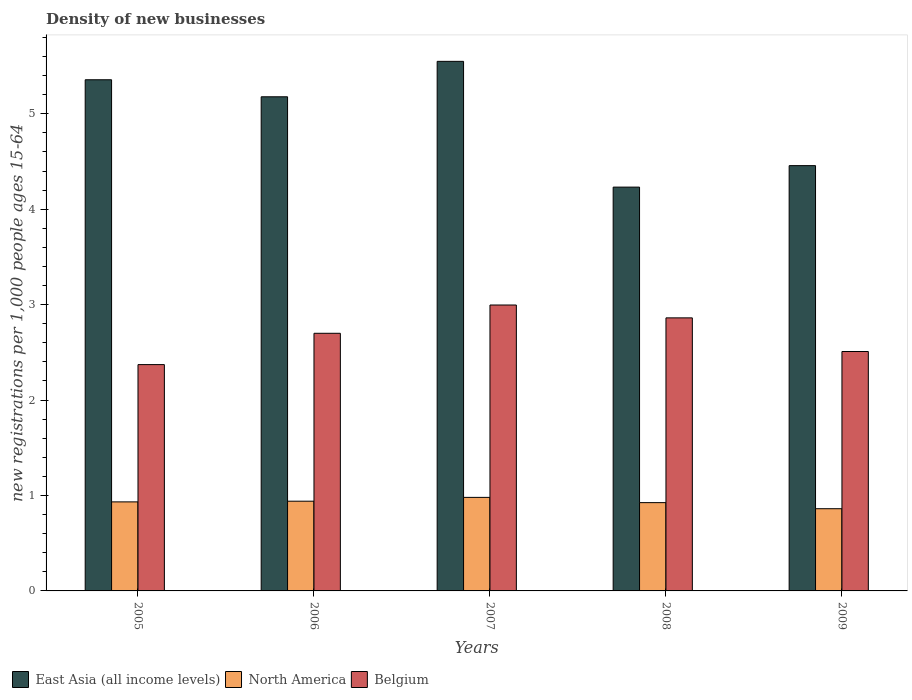How many groups of bars are there?
Make the answer very short. 5. Are the number of bars on each tick of the X-axis equal?
Make the answer very short. Yes. How many bars are there on the 2nd tick from the left?
Your answer should be compact. 3. How many bars are there on the 4th tick from the right?
Keep it short and to the point. 3. What is the label of the 3rd group of bars from the left?
Offer a very short reply. 2007. In how many cases, is the number of bars for a given year not equal to the number of legend labels?
Your answer should be very brief. 0. What is the number of new registrations in East Asia (all income levels) in 2008?
Your response must be concise. 4.23. Across all years, what is the maximum number of new registrations in North America?
Your response must be concise. 0.98. Across all years, what is the minimum number of new registrations in Belgium?
Offer a very short reply. 2.37. In which year was the number of new registrations in North America maximum?
Your answer should be very brief. 2007. In which year was the number of new registrations in East Asia (all income levels) minimum?
Make the answer very short. 2008. What is the total number of new registrations in Belgium in the graph?
Provide a succinct answer. 13.44. What is the difference between the number of new registrations in Belgium in 2005 and that in 2008?
Your response must be concise. -0.49. What is the difference between the number of new registrations in North America in 2008 and the number of new registrations in East Asia (all income levels) in 2007?
Provide a short and direct response. -4.62. What is the average number of new registrations in North America per year?
Provide a succinct answer. 0.93. In the year 2009, what is the difference between the number of new registrations in Belgium and number of new registrations in East Asia (all income levels)?
Your answer should be compact. -1.95. In how many years, is the number of new registrations in East Asia (all income levels) greater than 3.4?
Your answer should be very brief. 5. What is the ratio of the number of new registrations in North America in 2005 to that in 2007?
Offer a very short reply. 0.95. Is the number of new registrations in Belgium in 2008 less than that in 2009?
Provide a succinct answer. No. Is the difference between the number of new registrations in Belgium in 2008 and 2009 greater than the difference between the number of new registrations in East Asia (all income levels) in 2008 and 2009?
Your answer should be compact. Yes. What is the difference between the highest and the second highest number of new registrations in North America?
Make the answer very short. 0.04. What is the difference between the highest and the lowest number of new registrations in East Asia (all income levels)?
Give a very brief answer. 1.32. What does the 3rd bar from the left in 2008 represents?
Offer a terse response. Belgium. What does the 1st bar from the right in 2005 represents?
Your answer should be very brief. Belgium. Are all the bars in the graph horizontal?
Keep it short and to the point. No. Are the values on the major ticks of Y-axis written in scientific E-notation?
Your answer should be very brief. No. Where does the legend appear in the graph?
Give a very brief answer. Bottom left. What is the title of the graph?
Make the answer very short. Density of new businesses. What is the label or title of the X-axis?
Your answer should be very brief. Years. What is the label or title of the Y-axis?
Offer a terse response. New registrations per 1,0 people ages 15-64. What is the new registrations per 1,000 people ages 15-64 in East Asia (all income levels) in 2005?
Your answer should be very brief. 5.36. What is the new registrations per 1,000 people ages 15-64 in North America in 2005?
Your response must be concise. 0.93. What is the new registrations per 1,000 people ages 15-64 in Belgium in 2005?
Make the answer very short. 2.37. What is the new registrations per 1,000 people ages 15-64 in East Asia (all income levels) in 2006?
Provide a short and direct response. 5.18. What is the new registrations per 1,000 people ages 15-64 of North America in 2006?
Your answer should be compact. 0.94. What is the new registrations per 1,000 people ages 15-64 in Belgium in 2006?
Provide a succinct answer. 2.7. What is the new registrations per 1,000 people ages 15-64 in East Asia (all income levels) in 2007?
Your response must be concise. 5.55. What is the new registrations per 1,000 people ages 15-64 in North America in 2007?
Make the answer very short. 0.98. What is the new registrations per 1,000 people ages 15-64 in Belgium in 2007?
Give a very brief answer. 3. What is the new registrations per 1,000 people ages 15-64 in East Asia (all income levels) in 2008?
Give a very brief answer. 4.23. What is the new registrations per 1,000 people ages 15-64 in North America in 2008?
Offer a terse response. 0.93. What is the new registrations per 1,000 people ages 15-64 in Belgium in 2008?
Offer a terse response. 2.86. What is the new registrations per 1,000 people ages 15-64 in East Asia (all income levels) in 2009?
Give a very brief answer. 4.46. What is the new registrations per 1,000 people ages 15-64 in North America in 2009?
Ensure brevity in your answer.  0.86. What is the new registrations per 1,000 people ages 15-64 in Belgium in 2009?
Provide a succinct answer. 2.51. Across all years, what is the maximum new registrations per 1,000 people ages 15-64 in East Asia (all income levels)?
Your response must be concise. 5.55. Across all years, what is the maximum new registrations per 1,000 people ages 15-64 of North America?
Make the answer very short. 0.98. Across all years, what is the maximum new registrations per 1,000 people ages 15-64 of Belgium?
Offer a terse response. 3. Across all years, what is the minimum new registrations per 1,000 people ages 15-64 in East Asia (all income levels)?
Make the answer very short. 4.23. Across all years, what is the minimum new registrations per 1,000 people ages 15-64 in North America?
Provide a succinct answer. 0.86. Across all years, what is the minimum new registrations per 1,000 people ages 15-64 in Belgium?
Provide a short and direct response. 2.37. What is the total new registrations per 1,000 people ages 15-64 in East Asia (all income levels) in the graph?
Provide a short and direct response. 24.77. What is the total new registrations per 1,000 people ages 15-64 of North America in the graph?
Your answer should be very brief. 4.64. What is the total new registrations per 1,000 people ages 15-64 in Belgium in the graph?
Your response must be concise. 13.44. What is the difference between the new registrations per 1,000 people ages 15-64 of East Asia (all income levels) in 2005 and that in 2006?
Your answer should be very brief. 0.18. What is the difference between the new registrations per 1,000 people ages 15-64 of North America in 2005 and that in 2006?
Your answer should be very brief. -0.01. What is the difference between the new registrations per 1,000 people ages 15-64 in Belgium in 2005 and that in 2006?
Your answer should be compact. -0.33. What is the difference between the new registrations per 1,000 people ages 15-64 of East Asia (all income levels) in 2005 and that in 2007?
Offer a terse response. -0.19. What is the difference between the new registrations per 1,000 people ages 15-64 of North America in 2005 and that in 2007?
Give a very brief answer. -0.05. What is the difference between the new registrations per 1,000 people ages 15-64 of Belgium in 2005 and that in 2007?
Offer a terse response. -0.62. What is the difference between the new registrations per 1,000 people ages 15-64 of East Asia (all income levels) in 2005 and that in 2008?
Provide a short and direct response. 1.12. What is the difference between the new registrations per 1,000 people ages 15-64 in North America in 2005 and that in 2008?
Ensure brevity in your answer.  0.01. What is the difference between the new registrations per 1,000 people ages 15-64 in Belgium in 2005 and that in 2008?
Your response must be concise. -0.49. What is the difference between the new registrations per 1,000 people ages 15-64 of East Asia (all income levels) in 2005 and that in 2009?
Offer a very short reply. 0.9. What is the difference between the new registrations per 1,000 people ages 15-64 in North America in 2005 and that in 2009?
Your answer should be compact. 0.07. What is the difference between the new registrations per 1,000 people ages 15-64 of Belgium in 2005 and that in 2009?
Your response must be concise. -0.14. What is the difference between the new registrations per 1,000 people ages 15-64 in East Asia (all income levels) in 2006 and that in 2007?
Provide a succinct answer. -0.37. What is the difference between the new registrations per 1,000 people ages 15-64 in North America in 2006 and that in 2007?
Provide a succinct answer. -0.04. What is the difference between the new registrations per 1,000 people ages 15-64 in Belgium in 2006 and that in 2007?
Provide a short and direct response. -0.3. What is the difference between the new registrations per 1,000 people ages 15-64 in East Asia (all income levels) in 2006 and that in 2008?
Offer a very short reply. 0.95. What is the difference between the new registrations per 1,000 people ages 15-64 of North America in 2006 and that in 2008?
Keep it short and to the point. 0.01. What is the difference between the new registrations per 1,000 people ages 15-64 in Belgium in 2006 and that in 2008?
Make the answer very short. -0.16. What is the difference between the new registrations per 1,000 people ages 15-64 of East Asia (all income levels) in 2006 and that in 2009?
Offer a very short reply. 0.72. What is the difference between the new registrations per 1,000 people ages 15-64 in North America in 2006 and that in 2009?
Offer a terse response. 0.08. What is the difference between the new registrations per 1,000 people ages 15-64 in Belgium in 2006 and that in 2009?
Offer a terse response. 0.19. What is the difference between the new registrations per 1,000 people ages 15-64 of East Asia (all income levels) in 2007 and that in 2008?
Keep it short and to the point. 1.32. What is the difference between the new registrations per 1,000 people ages 15-64 of North America in 2007 and that in 2008?
Give a very brief answer. 0.06. What is the difference between the new registrations per 1,000 people ages 15-64 in Belgium in 2007 and that in 2008?
Provide a short and direct response. 0.13. What is the difference between the new registrations per 1,000 people ages 15-64 in East Asia (all income levels) in 2007 and that in 2009?
Provide a short and direct response. 1.09. What is the difference between the new registrations per 1,000 people ages 15-64 of North America in 2007 and that in 2009?
Give a very brief answer. 0.12. What is the difference between the new registrations per 1,000 people ages 15-64 in Belgium in 2007 and that in 2009?
Provide a succinct answer. 0.49. What is the difference between the new registrations per 1,000 people ages 15-64 of East Asia (all income levels) in 2008 and that in 2009?
Provide a succinct answer. -0.23. What is the difference between the new registrations per 1,000 people ages 15-64 in North America in 2008 and that in 2009?
Your answer should be very brief. 0.06. What is the difference between the new registrations per 1,000 people ages 15-64 in Belgium in 2008 and that in 2009?
Offer a terse response. 0.35. What is the difference between the new registrations per 1,000 people ages 15-64 in East Asia (all income levels) in 2005 and the new registrations per 1,000 people ages 15-64 in North America in 2006?
Offer a terse response. 4.42. What is the difference between the new registrations per 1,000 people ages 15-64 in East Asia (all income levels) in 2005 and the new registrations per 1,000 people ages 15-64 in Belgium in 2006?
Make the answer very short. 2.66. What is the difference between the new registrations per 1,000 people ages 15-64 of North America in 2005 and the new registrations per 1,000 people ages 15-64 of Belgium in 2006?
Offer a very short reply. -1.77. What is the difference between the new registrations per 1,000 people ages 15-64 in East Asia (all income levels) in 2005 and the new registrations per 1,000 people ages 15-64 in North America in 2007?
Your response must be concise. 4.38. What is the difference between the new registrations per 1,000 people ages 15-64 in East Asia (all income levels) in 2005 and the new registrations per 1,000 people ages 15-64 in Belgium in 2007?
Ensure brevity in your answer.  2.36. What is the difference between the new registrations per 1,000 people ages 15-64 in North America in 2005 and the new registrations per 1,000 people ages 15-64 in Belgium in 2007?
Ensure brevity in your answer.  -2.06. What is the difference between the new registrations per 1,000 people ages 15-64 in East Asia (all income levels) in 2005 and the new registrations per 1,000 people ages 15-64 in North America in 2008?
Your answer should be compact. 4.43. What is the difference between the new registrations per 1,000 people ages 15-64 in East Asia (all income levels) in 2005 and the new registrations per 1,000 people ages 15-64 in Belgium in 2008?
Provide a short and direct response. 2.5. What is the difference between the new registrations per 1,000 people ages 15-64 in North America in 2005 and the new registrations per 1,000 people ages 15-64 in Belgium in 2008?
Provide a succinct answer. -1.93. What is the difference between the new registrations per 1,000 people ages 15-64 of East Asia (all income levels) in 2005 and the new registrations per 1,000 people ages 15-64 of North America in 2009?
Your response must be concise. 4.49. What is the difference between the new registrations per 1,000 people ages 15-64 in East Asia (all income levels) in 2005 and the new registrations per 1,000 people ages 15-64 in Belgium in 2009?
Make the answer very short. 2.85. What is the difference between the new registrations per 1,000 people ages 15-64 in North America in 2005 and the new registrations per 1,000 people ages 15-64 in Belgium in 2009?
Your answer should be compact. -1.58. What is the difference between the new registrations per 1,000 people ages 15-64 of East Asia (all income levels) in 2006 and the new registrations per 1,000 people ages 15-64 of North America in 2007?
Give a very brief answer. 4.2. What is the difference between the new registrations per 1,000 people ages 15-64 in East Asia (all income levels) in 2006 and the new registrations per 1,000 people ages 15-64 in Belgium in 2007?
Provide a short and direct response. 2.18. What is the difference between the new registrations per 1,000 people ages 15-64 of North America in 2006 and the new registrations per 1,000 people ages 15-64 of Belgium in 2007?
Keep it short and to the point. -2.06. What is the difference between the new registrations per 1,000 people ages 15-64 in East Asia (all income levels) in 2006 and the new registrations per 1,000 people ages 15-64 in North America in 2008?
Your answer should be compact. 4.25. What is the difference between the new registrations per 1,000 people ages 15-64 of East Asia (all income levels) in 2006 and the new registrations per 1,000 people ages 15-64 of Belgium in 2008?
Keep it short and to the point. 2.32. What is the difference between the new registrations per 1,000 people ages 15-64 in North America in 2006 and the new registrations per 1,000 people ages 15-64 in Belgium in 2008?
Give a very brief answer. -1.92. What is the difference between the new registrations per 1,000 people ages 15-64 in East Asia (all income levels) in 2006 and the new registrations per 1,000 people ages 15-64 in North America in 2009?
Keep it short and to the point. 4.32. What is the difference between the new registrations per 1,000 people ages 15-64 in East Asia (all income levels) in 2006 and the new registrations per 1,000 people ages 15-64 in Belgium in 2009?
Ensure brevity in your answer.  2.67. What is the difference between the new registrations per 1,000 people ages 15-64 of North America in 2006 and the new registrations per 1,000 people ages 15-64 of Belgium in 2009?
Make the answer very short. -1.57. What is the difference between the new registrations per 1,000 people ages 15-64 of East Asia (all income levels) in 2007 and the new registrations per 1,000 people ages 15-64 of North America in 2008?
Your answer should be compact. 4.62. What is the difference between the new registrations per 1,000 people ages 15-64 in East Asia (all income levels) in 2007 and the new registrations per 1,000 people ages 15-64 in Belgium in 2008?
Offer a very short reply. 2.69. What is the difference between the new registrations per 1,000 people ages 15-64 in North America in 2007 and the new registrations per 1,000 people ages 15-64 in Belgium in 2008?
Make the answer very short. -1.88. What is the difference between the new registrations per 1,000 people ages 15-64 of East Asia (all income levels) in 2007 and the new registrations per 1,000 people ages 15-64 of North America in 2009?
Make the answer very short. 4.69. What is the difference between the new registrations per 1,000 people ages 15-64 in East Asia (all income levels) in 2007 and the new registrations per 1,000 people ages 15-64 in Belgium in 2009?
Your answer should be very brief. 3.04. What is the difference between the new registrations per 1,000 people ages 15-64 in North America in 2007 and the new registrations per 1,000 people ages 15-64 in Belgium in 2009?
Provide a short and direct response. -1.53. What is the difference between the new registrations per 1,000 people ages 15-64 in East Asia (all income levels) in 2008 and the new registrations per 1,000 people ages 15-64 in North America in 2009?
Your answer should be compact. 3.37. What is the difference between the new registrations per 1,000 people ages 15-64 in East Asia (all income levels) in 2008 and the new registrations per 1,000 people ages 15-64 in Belgium in 2009?
Keep it short and to the point. 1.72. What is the difference between the new registrations per 1,000 people ages 15-64 of North America in 2008 and the new registrations per 1,000 people ages 15-64 of Belgium in 2009?
Provide a succinct answer. -1.58. What is the average new registrations per 1,000 people ages 15-64 in East Asia (all income levels) per year?
Provide a succinct answer. 4.95. What is the average new registrations per 1,000 people ages 15-64 of North America per year?
Offer a very short reply. 0.93. What is the average new registrations per 1,000 people ages 15-64 of Belgium per year?
Provide a succinct answer. 2.69. In the year 2005, what is the difference between the new registrations per 1,000 people ages 15-64 in East Asia (all income levels) and new registrations per 1,000 people ages 15-64 in North America?
Your response must be concise. 4.42. In the year 2005, what is the difference between the new registrations per 1,000 people ages 15-64 in East Asia (all income levels) and new registrations per 1,000 people ages 15-64 in Belgium?
Keep it short and to the point. 2.98. In the year 2005, what is the difference between the new registrations per 1,000 people ages 15-64 of North America and new registrations per 1,000 people ages 15-64 of Belgium?
Make the answer very short. -1.44. In the year 2006, what is the difference between the new registrations per 1,000 people ages 15-64 of East Asia (all income levels) and new registrations per 1,000 people ages 15-64 of North America?
Your response must be concise. 4.24. In the year 2006, what is the difference between the new registrations per 1,000 people ages 15-64 in East Asia (all income levels) and new registrations per 1,000 people ages 15-64 in Belgium?
Offer a very short reply. 2.48. In the year 2006, what is the difference between the new registrations per 1,000 people ages 15-64 in North America and new registrations per 1,000 people ages 15-64 in Belgium?
Provide a succinct answer. -1.76. In the year 2007, what is the difference between the new registrations per 1,000 people ages 15-64 of East Asia (all income levels) and new registrations per 1,000 people ages 15-64 of North America?
Keep it short and to the point. 4.57. In the year 2007, what is the difference between the new registrations per 1,000 people ages 15-64 of East Asia (all income levels) and new registrations per 1,000 people ages 15-64 of Belgium?
Your answer should be compact. 2.55. In the year 2007, what is the difference between the new registrations per 1,000 people ages 15-64 of North America and new registrations per 1,000 people ages 15-64 of Belgium?
Offer a terse response. -2.02. In the year 2008, what is the difference between the new registrations per 1,000 people ages 15-64 in East Asia (all income levels) and new registrations per 1,000 people ages 15-64 in North America?
Offer a very short reply. 3.31. In the year 2008, what is the difference between the new registrations per 1,000 people ages 15-64 in East Asia (all income levels) and new registrations per 1,000 people ages 15-64 in Belgium?
Make the answer very short. 1.37. In the year 2008, what is the difference between the new registrations per 1,000 people ages 15-64 in North America and new registrations per 1,000 people ages 15-64 in Belgium?
Keep it short and to the point. -1.94. In the year 2009, what is the difference between the new registrations per 1,000 people ages 15-64 in East Asia (all income levels) and new registrations per 1,000 people ages 15-64 in North America?
Your answer should be compact. 3.6. In the year 2009, what is the difference between the new registrations per 1,000 people ages 15-64 of East Asia (all income levels) and new registrations per 1,000 people ages 15-64 of Belgium?
Your response must be concise. 1.95. In the year 2009, what is the difference between the new registrations per 1,000 people ages 15-64 of North America and new registrations per 1,000 people ages 15-64 of Belgium?
Keep it short and to the point. -1.65. What is the ratio of the new registrations per 1,000 people ages 15-64 in East Asia (all income levels) in 2005 to that in 2006?
Keep it short and to the point. 1.03. What is the ratio of the new registrations per 1,000 people ages 15-64 in Belgium in 2005 to that in 2006?
Offer a very short reply. 0.88. What is the ratio of the new registrations per 1,000 people ages 15-64 in East Asia (all income levels) in 2005 to that in 2007?
Provide a short and direct response. 0.97. What is the ratio of the new registrations per 1,000 people ages 15-64 in North America in 2005 to that in 2007?
Provide a succinct answer. 0.95. What is the ratio of the new registrations per 1,000 people ages 15-64 in Belgium in 2005 to that in 2007?
Your response must be concise. 0.79. What is the ratio of the new registrations per 1,000 people ages 15-64 of East Asia (all income levels) in 2005 to that in 2008?
Offer a terse response. 1.27. What is the ratio of the new registrations per 1,000 people ages 15-64 in North America in 2005 to that in 2008?
Give a very brief answer. 1.01. What is the ratio of the new registrations per 1,000 people ages 15-64 of Belgium in 2005 to that in 2008?
Offer a very short reply. 0.83. What is the ratio of the new registrations per 1,000 people ages 15-64 in East Asia (all income levels) in 2005 to that in 2009?
Provide a short and direct response. 1.2. What is the ratio of the new registrations per 1,000 people ages 15-64 of North America in 2005 to that in 2009?
Provide a short and direct response. 1.08. What is the ratio of the new registrations per 1,000 people ages 15-64 in Belgium in 2005 to that in 2009?
Keep it short and to the point. 0.95. What is the ratio of the new registrations per 1,000 people ages 15-64 of East Asia (all income levels) in 2006 to that in 2007?
Keep it short and to the point. 0.93. What is the ratio of the new registrations per 1,000 people ages 15-64 of North America in 2006 to that in 2007?
Offer a very short reply. 0.96. What is the ratio of the new registrations per 1,000 people ages 15-64 of Belgium in 2006 to that in 2007?
Your answer should be very brief. 0.9. What is the ratio of the new registrations per 1,000 people ages 15-64 in East Asia (all income levels) in 2006 to that in 2008?
Ensure brevity in your answer.  1.22. What is the ratio of the new registrations per 1,000 people ages 15-64 in North America in 2006 to that in 2008?
Ensure brevity in your answer.  1.02. What is the ratio of the new registrations per 1,000 people ages 15-64 in Belgium in 2006 to that in 2008?
Offer a terse response. 0.94. What is the ratio of the new registrations per 1,000 people ages 15-64 in East Asia (all income levels) in 2006 to that in 2009?
Your answer should be compact. 1.16. What is the ratio of the new registrations per 1,000 people ages 15-64 in North America in 2006 to that in 2009?
Make the answer very short. 1.09. What is the ratio of the new registrations per 1,000 people ages 15-64 in Belgium in 2006 to that in 2009?
Your answer should be compact. 1.08. What is the ratio of the new registrations per 1,000 people ages 15-64 of East Asia (all income levels) in 2007 to that in 2008?
Your answer should be compact. 1.31. What is the ratio of the new registrations per 1,000 people ages 15-64 in North America in 2007 to that in 2008?
Your answer should be very brief. 1.06. What is the ratio of the new registrations per 1,000 people ages 15-64 of Belgium in 2007 to that in 2008?
Your answer should be compact. 1.05. What is the ratio of the new registrations per 1,000 people ages 15-64 in East Asia (all income levels) in 2007 to that in 2009?
Make the answer very short. 1.25. What is the ratio of the new registrations per 1,000 people ages 15-64 of North America in 2007 to that in 2009?
Provide a succinct answer. 1.14. What is the ratio of the new registrations per 1,000 people ages 15-64 of Belgium in 2007 to that in 2009?
Provide a short and direct response. 1.19. What is the ratio of the new registrations per 1,000 people ages 15-64 in East Asia (all income levels) in 2008 to that in 2009?
Your answer should be compact. 0.95. What is the ratio of the new registrations per 1,000 people ages 15-64 of North America in 2008 to that in 2009?
Your response must be concise. 1.07. What is the ratio of the new registrations per 1,000 people ages 15-64 of Belgium in 2008 to that in 2009?
Give a very brief answer. 1.14. What is the difference between the highest and the second highest new registrations per 1,000 people ages 15-64 of East Asia (all income levels)?
Offer a very short reply. 0.19. What is the difference between the highest and the second highest new registrations per 1,000 people ages 15-64 in Belgium?
Provide a short and direct response. 0.13. What is the difference between the highest and the lowest new registrations per 1,000 people ages 15-64 of East Asia (all income levels)?
Provide a succinct answer. 1.32. What is the difference between the highest and the lowest new registrations per 1,000 people ages 15-64 of North America?
Your response must be concise. 0.12. What is the difference between the highest and the lowest new registrations per 1,000 people ages 15-64 of Belgium?
Provide a succinct answer. 0.62. 